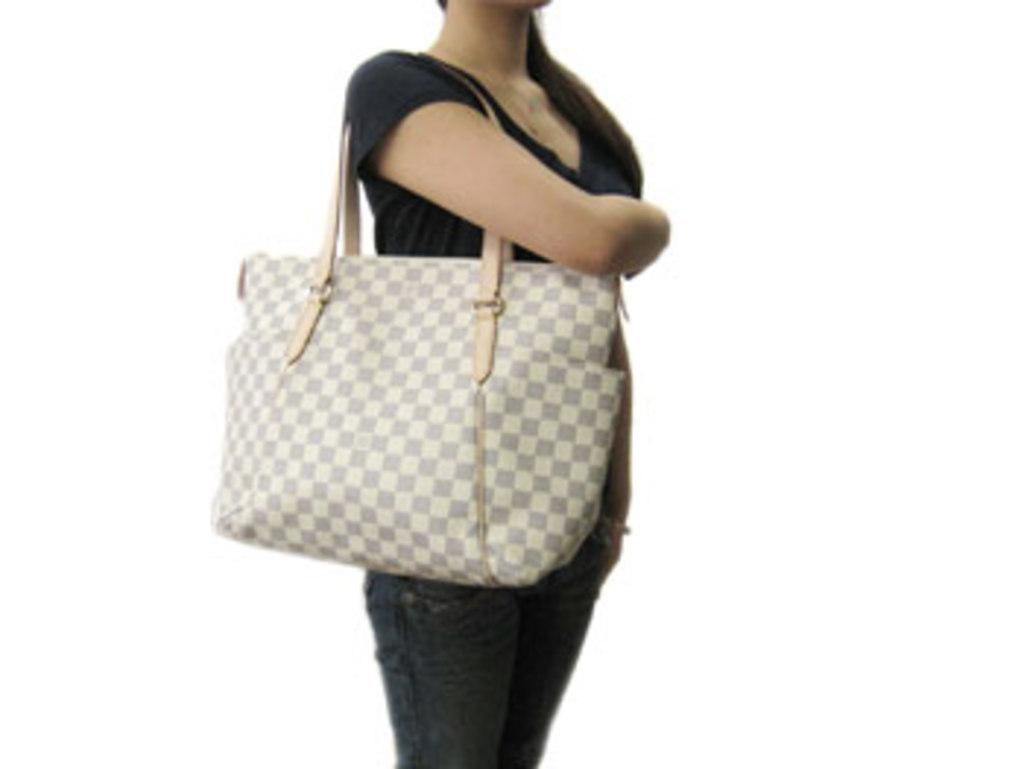Who is the main subject in the image? There is a woman in the image. What is the woman wearing? The woman is wearing a black dress. What is the woman doing in the image? The woman is standing. What is the woman holding in her right hand? The woman is holding a white bag in her right hand. What type of cream can be seen growing from the woman's feet in the image? There is no cream or any plant-like growth visible on the woman's feet in the image. 